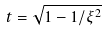<formula> <loc_0><loc_0><loc_500><loc_500>t = \sqrt { 1 - 1 / \xi ^ { 2 } }</formula> 